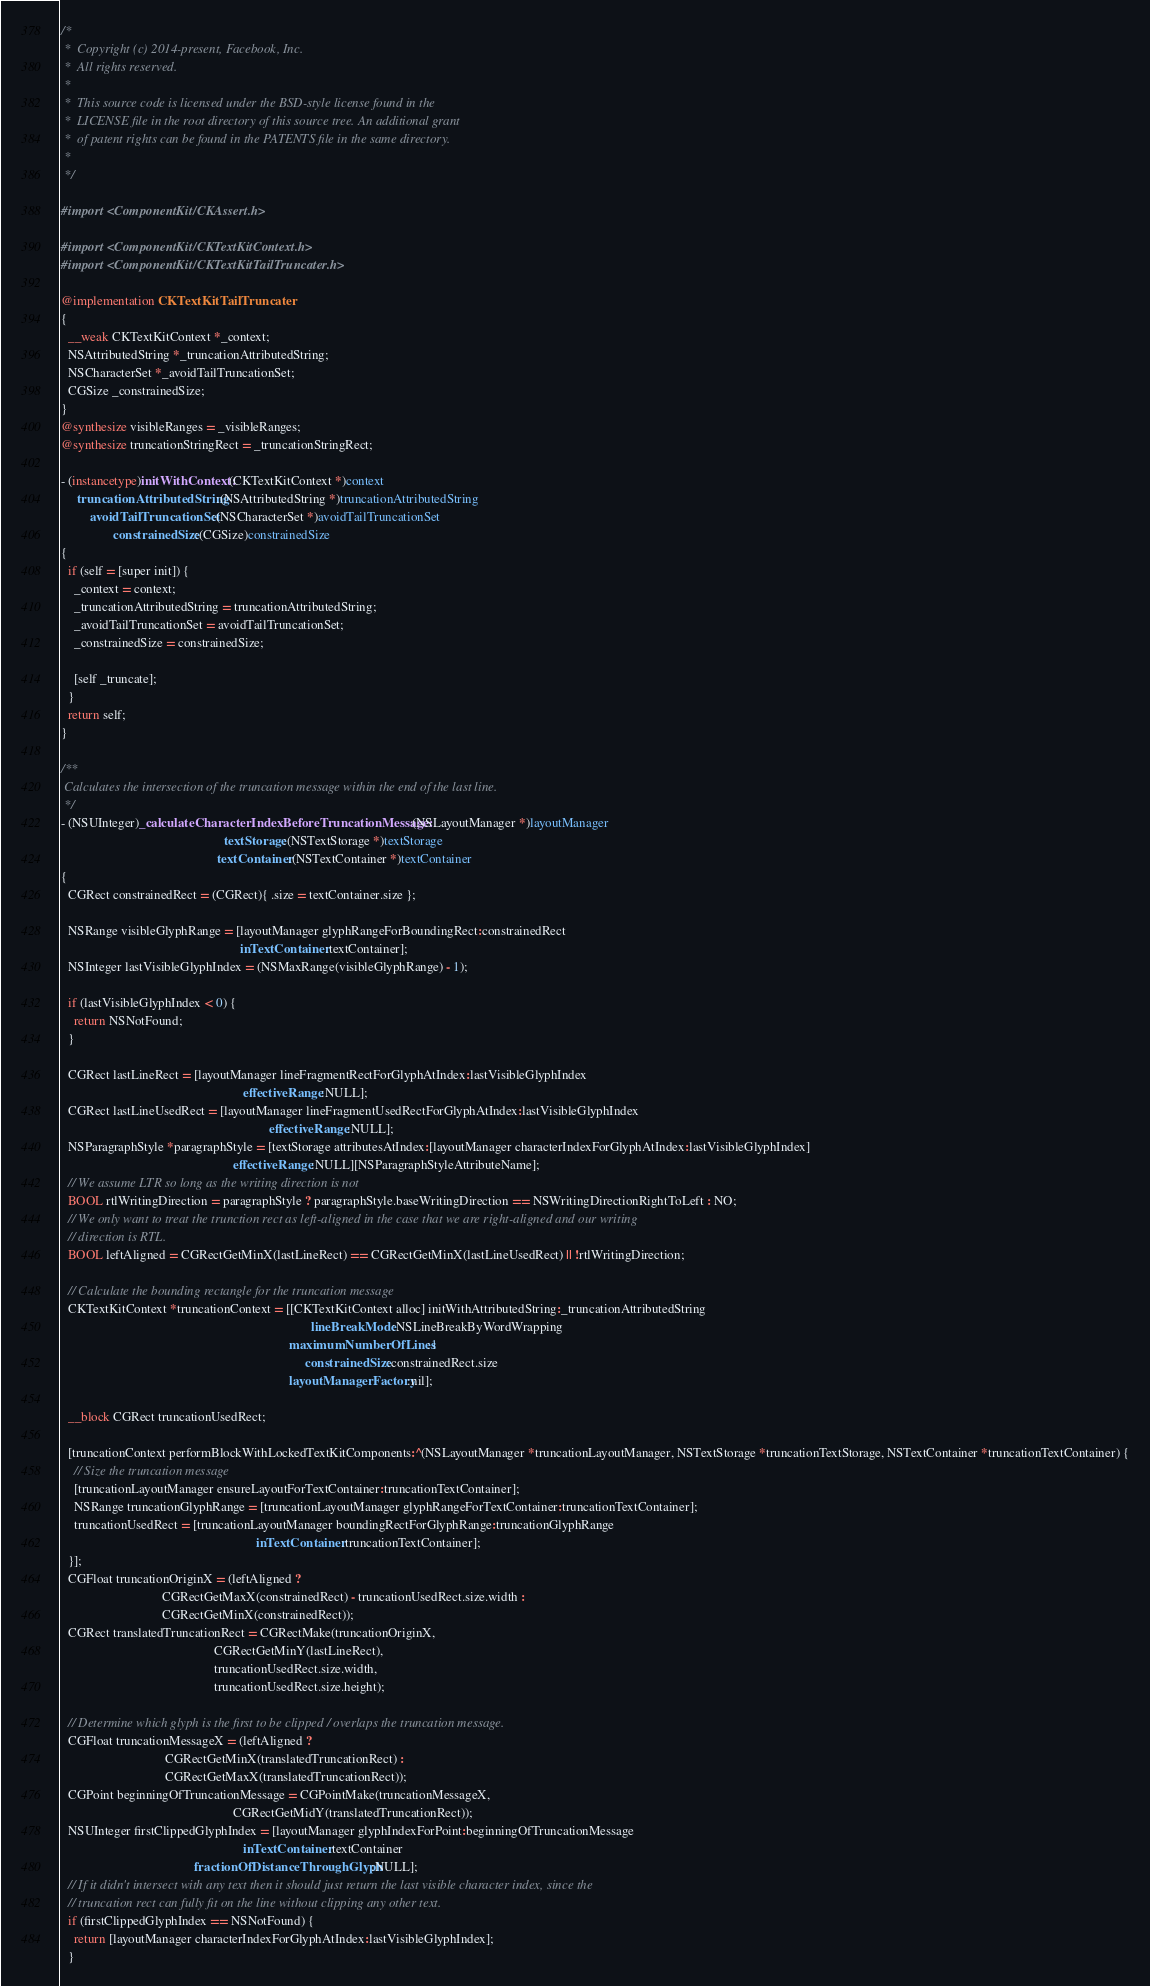Convert code to text. <code><loc_0><loc_0><loc_500><loc_500><_ObjectiveC_>/*
 *  Copyright (c) 2014-present, Facebook, Inc.
 *  All rights reserved.
 *
 *  This source code is licensed under the BSD-style license found in the
 *  LICENSE file in the root directory of this source tree. An additional grant
 *  of patent rights can be found in the PATENTS file in the same directory.
 *
 */

#import <ComponentKit/CKAssert.h>

#import <ComponentKit/CKTextKitContext.h>
#import <ComponentKit/CKTextKitTailTruncater.h>

@implementation CKTextKitTailTruncater
{
  __weak CKTextKitContext *_context;
  NSAttributedString *_truncationAttributedString;
  NSCharacterSet *_avoidTailTruncationSet;
  CGSize _constrainedSize;
}
@synthesize visibleRanges = _visibleRanges;
@synthesize truncationStringRect = _truncationStringRect;

- (instancetype)initWithContext:(CKTextKitContext *)context
     truncationAttributedString:(NSAttributedString *)truncationAttributedString
         avoidTailTruncationSet:(NSCharacterSet *)avoidTailTruncationSet
                constrainedSize:(CGSize)constrainedSize
{
  if (self = [super init]) {
    _context = context;
    _truncationAttributedString = truncationAttributedString;
    _avoidTailTruncationSet = avoidTailTruncationSet;
    _constrainedSize = constrainedSize;

    [self _truncate];
  }
  return self;
}

/**
 Calculates the intersection of the truncation message within the end of the last line.
 */
- (NSUInteger)_calculateCharacterIndexBeforeTruncationMessage:(NSLayoutManager *)layoutManager
                                                  textStorage:(NSTextStorage *)textStorage
                                                textContainer:(NSTextContainer *)textContainer
{
  CGRect constrainedRect = (CGRect){ .size = textContainer.size };

  NSRange visibleGlyphRange = [layoutManager glyphRangeForBoundingRect:constrainedRect
                                                       inTextContainer:textContainer];
  NSInteger lastVisibleGlyphIndex = (NSMaxRange(visibleGlyphRange) - 1);

  if (lastVisibleGlyphIndex < 0) {
    return NSNotFound;
  }

  CGRect lastLineRect = [layoutManager lineFragmentRectForGlyphAtIndex:lastVisibleGlyphIndex
                                                        effectiveRange:NULL];
  CGRect lastLineUsedRect = [layoutManager lineFragmentUsedRectForGlyphAtIndex:lastVisibleGlyphIndex
                                                                effectiveRange:NULL];
  NSParagraphStyle *paragraphStyle = [textStorage attributesAtIndex:[layoutManager characterIndexForGlyphAtIndex:lastVisibleGlyphIndex]
                                                     effectiveRange:NULL][NSParagraphStyleAttributeName];
  // We assume LTR so long as the writing direction is not
  BOOL rtlWritingDirection = paragraphStyle ? paragraphStyle.baseWritingDirection == NSWritingDirectionRightToLeft : NO;
  // We only want to treat the trunction rect as left-aligned in the case that we are right-aligned and our writing
  // direction is RTL.
  BOOL leftAligned = CGRectGetMinX(lastLineRect) == CGRectGetMinX(lastLineUsedRect) || !rtlWritingDirection;

  // Calculate the bounding rectangle for the truncation message
  CKTextKitContext *truncationContext = [[CKTextKitContext alloc] initWithAttributedString:_truncationAttributedString
                                                                             lineBreakMode:NSLineBreakByWordWrapping
                                                                      maximumNumberOfLines:1
                                                                           constrainedSize:constrainedRect.size
                                                                      layoutManagerFactory:nil];

  __block CGRect truncationUsedRect;

  [truncationContext performBlockWithLockedTextKitComponents:^(NSLayoutManager *truncationLayoutManager, NSTextStorage *truncationTextStorage, NSTextContainer *truncationTextContainer) {
    // Size the truncation message
    [truncationLayoutManager ensureLayoutForTextContainer:truncationTextContainer];
    NSRange truncationGlyphRange = [truncationLayoutManager glyphRangeForTextContainer:truncationTextContainer];
    truncationUsedRect = [truncationLayoutManager boundingRectForGlyphRange:truncationGlyphRange
                                                            inTextContainer:truncationTextContainer];
  }];
  CGFloat truncationOriginX = (leftAligned ?
                               CGRectGetMaxX(constrainedRect) - truncationUsedRect.size.width :
                               CGRectGetMinX(constrainedRect));
  CGRect translatedTruncationRect = CGRectMake(truncationOriginX,
                                               CGRectGetMinY(lastLineRect),
                                               truncationUsedRect.size.width,
                                               truncationUsedRect.size.height);

  // Determine which glyph is the first to be clipped / overlaps the truncation message.
  CGFloat truncationMessageX = (leftAligned ?
                                CGRectGetMinX(translatedTruncationRect) :
                                CGRectGetMaxX(translatedTruncationRect));
  CGPoint beginningOfTruncationMessage = CGPointMake(truncationMessageX,
                                                     CGRectGetMidY(translatedTruncationRect));
  NSUInteger firstClippedGlyphIndex = [layoutManager glyphIndexForPoint:beginningOfTruncationMessage
                                                        inTextContainer:textContainer
                                         fractionOfDistanceThroughGlyph:NULL];
  // If it didn't intersect with any text then it should just return the last visible character index, since the
  // truncation rect can fully fit on the line without clipping any other text.
  if (firstClippedGlyphIndex == NSNotFound) {
    return [layoutManager characterIndexForGlyphAtIndex:lastVisibleGlyphIndex];
  }</code> 